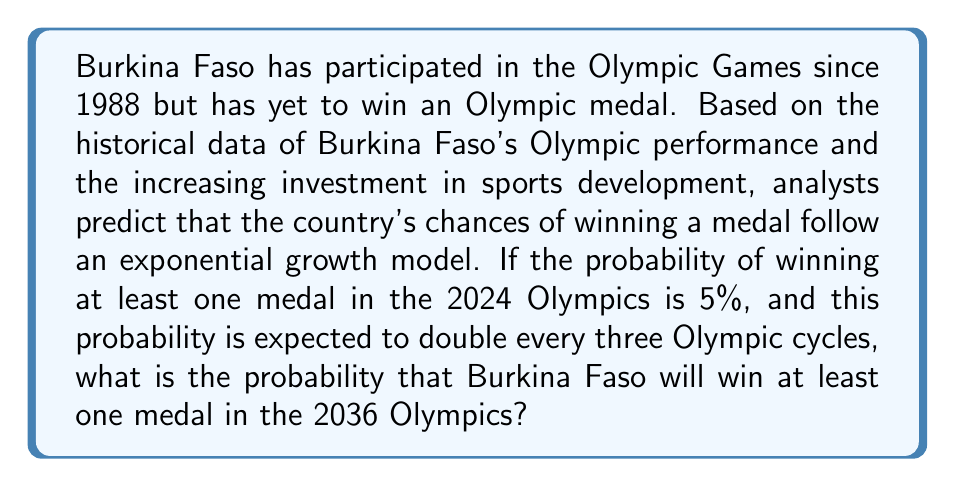Can you answer this question? Let's approach this step-by-step:

1) First, we need to identify the growth rate. We're told that the probability doubles every three Olympic cycles. Let's express this mathematically:

   $P_{t+3} = 2P_t$, where $P_t$ is the probability at time $t$.

2) For exponential growth, we can express this as:

   $P_t = P_0 \cdot (1+r)^t$

   Where $P_0$ is the initial probability, $r$ is the growth rate per cycle, and $t$ is the number of cycles.

3) We know that after 3 cycles, the probability doubles. So:

   $2 = (1+r)^3$

4) Solving for $r$:

   $\sqrt[3]{2} = 1+r$
   $r = \sqrt[3]{2} - 1 \approx 0.2599$ or about 26% growth per cycle

5) Now, we know that the probability for 2024 is 5% or 0.05. We need to find the probability for 2036, which is 4 cycles later.

6) Let's use our exponential growth formula:

   $P_{2036} = 0.05 \cdot (1.2599)^4$

7) Calculate:

   $P_{2036} = 0.05 \cdot 2.5198 = 0.1260$

8) Convert to a percentage:

   $0.1260 \cdot 100\% = 12.60\%$
Answer: The probability that Burkina Faso will win at least one medal in the 2036 Olympics is approximately 12.60%. 